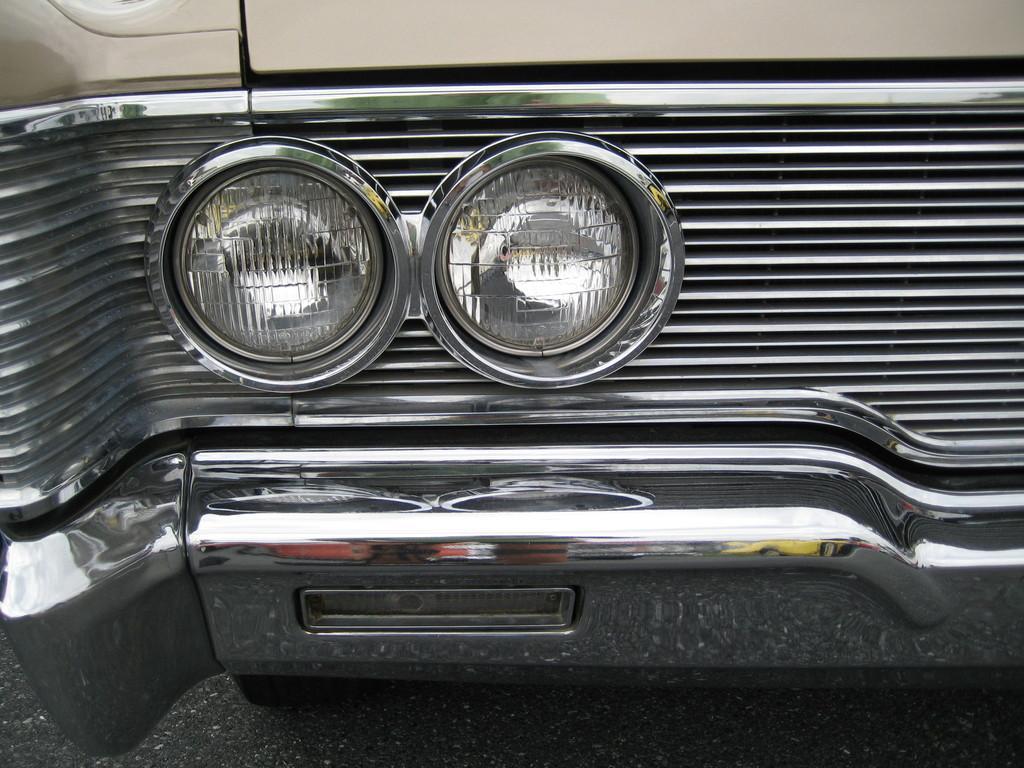In one or two sentences, can you explain what this image depicts? In this image we can see the headlights of a vehicle. At the bottom there is road. Around the headlights there is a metal object. 